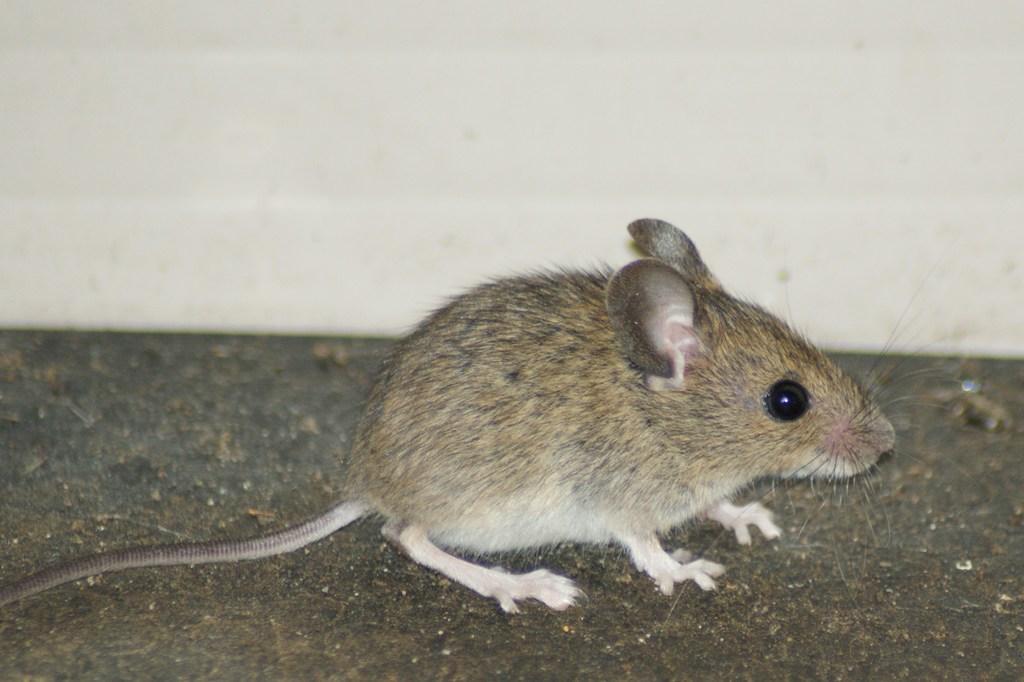Could you give a brief overview of what you see in this image? In this image, we can see a rat. We can see the ground with an object. We can also see the wall. 